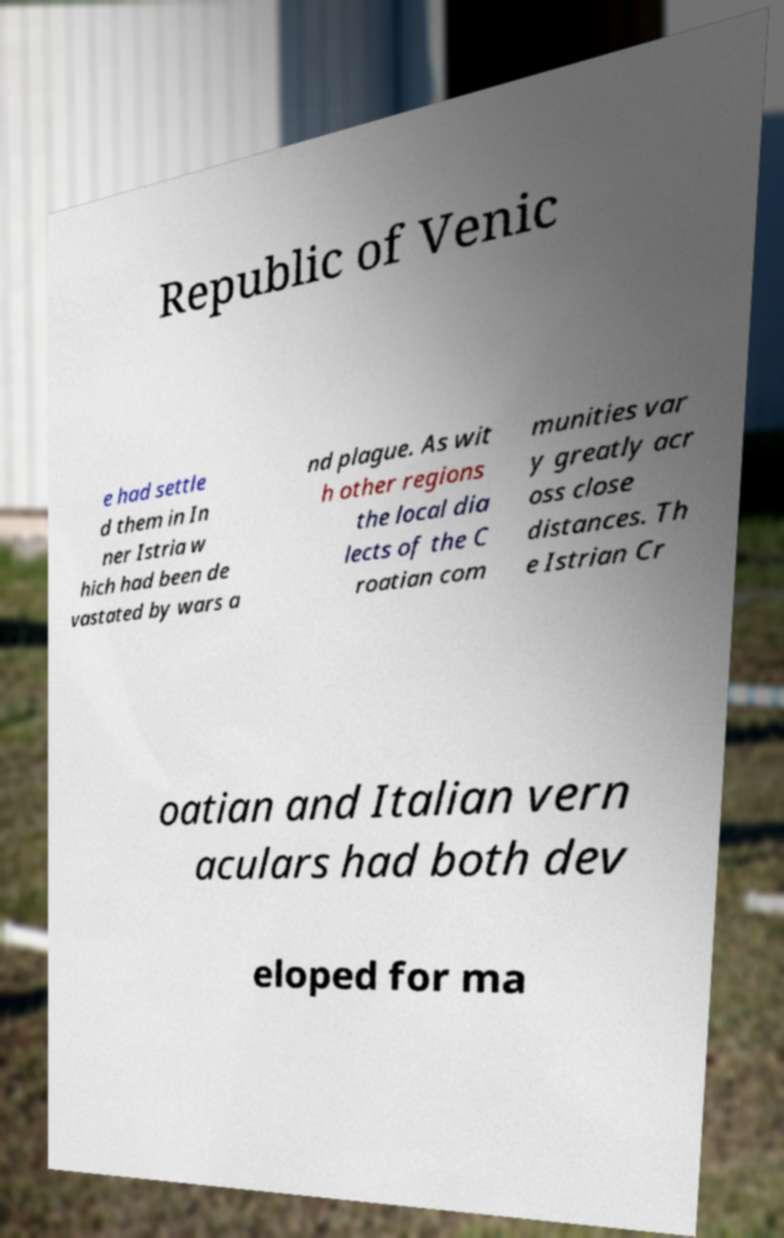Can you accurately transcribe the text from the provided image for me? Republic of Venic e had settle d them in In ner Istria w hich had been de vastated by wars a nd plague. As wit h other regions the local dia lects of the C roatian com munities var y greatly acr oss close distances. Th e Istrian Cr oatian and Italian vern aculars had both dev eloped for ma 